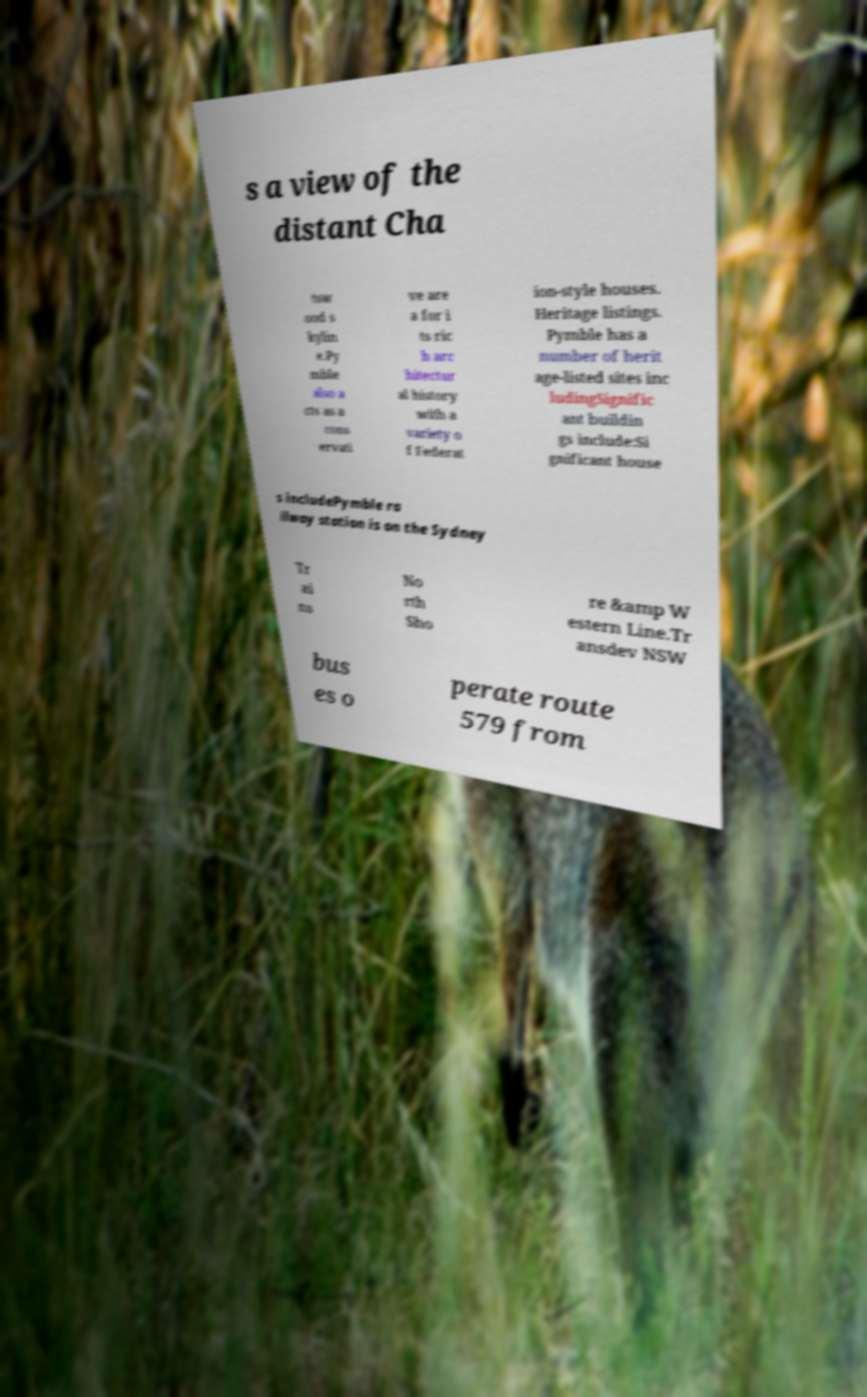What messages or text are displayed in this image? I need them in a readable, typed format. s a view of the distant Cha tsw ood s kylin e.Py mble also a cts as a cons ervati ve are a for i ts ric h arc hitectur al history with a variety o f Federat ion-style houses. Heritage listings. Pymble has a number of herit age-listed sites inc ludingSignific ant buildin gs include:Si gnificant house s includePymble ra ilway station is on the Sydney Tr ai ns No rth Sho re &amp W estern Line.Tr ansdev NSW bus es o perate route 579 from 